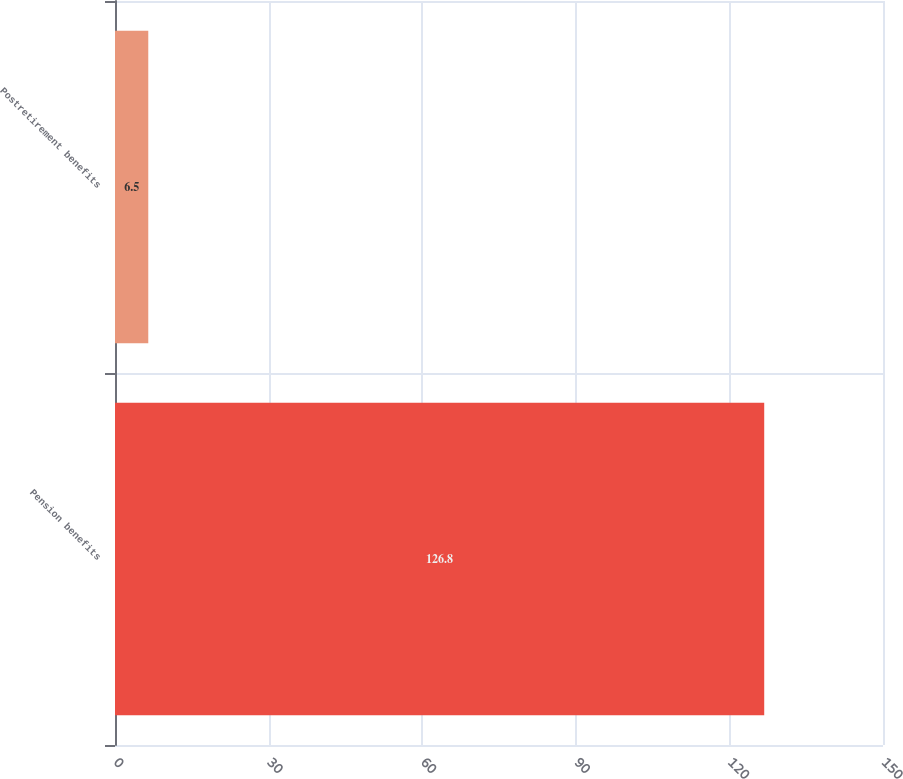<chart> <loc_0><loc_0><loc_500><loc_500><bar_chart><fcel>Pension benefits<fcel>Postretirement benefits<nl><fcel>126.8<fcel>6.5<nl></chart> 